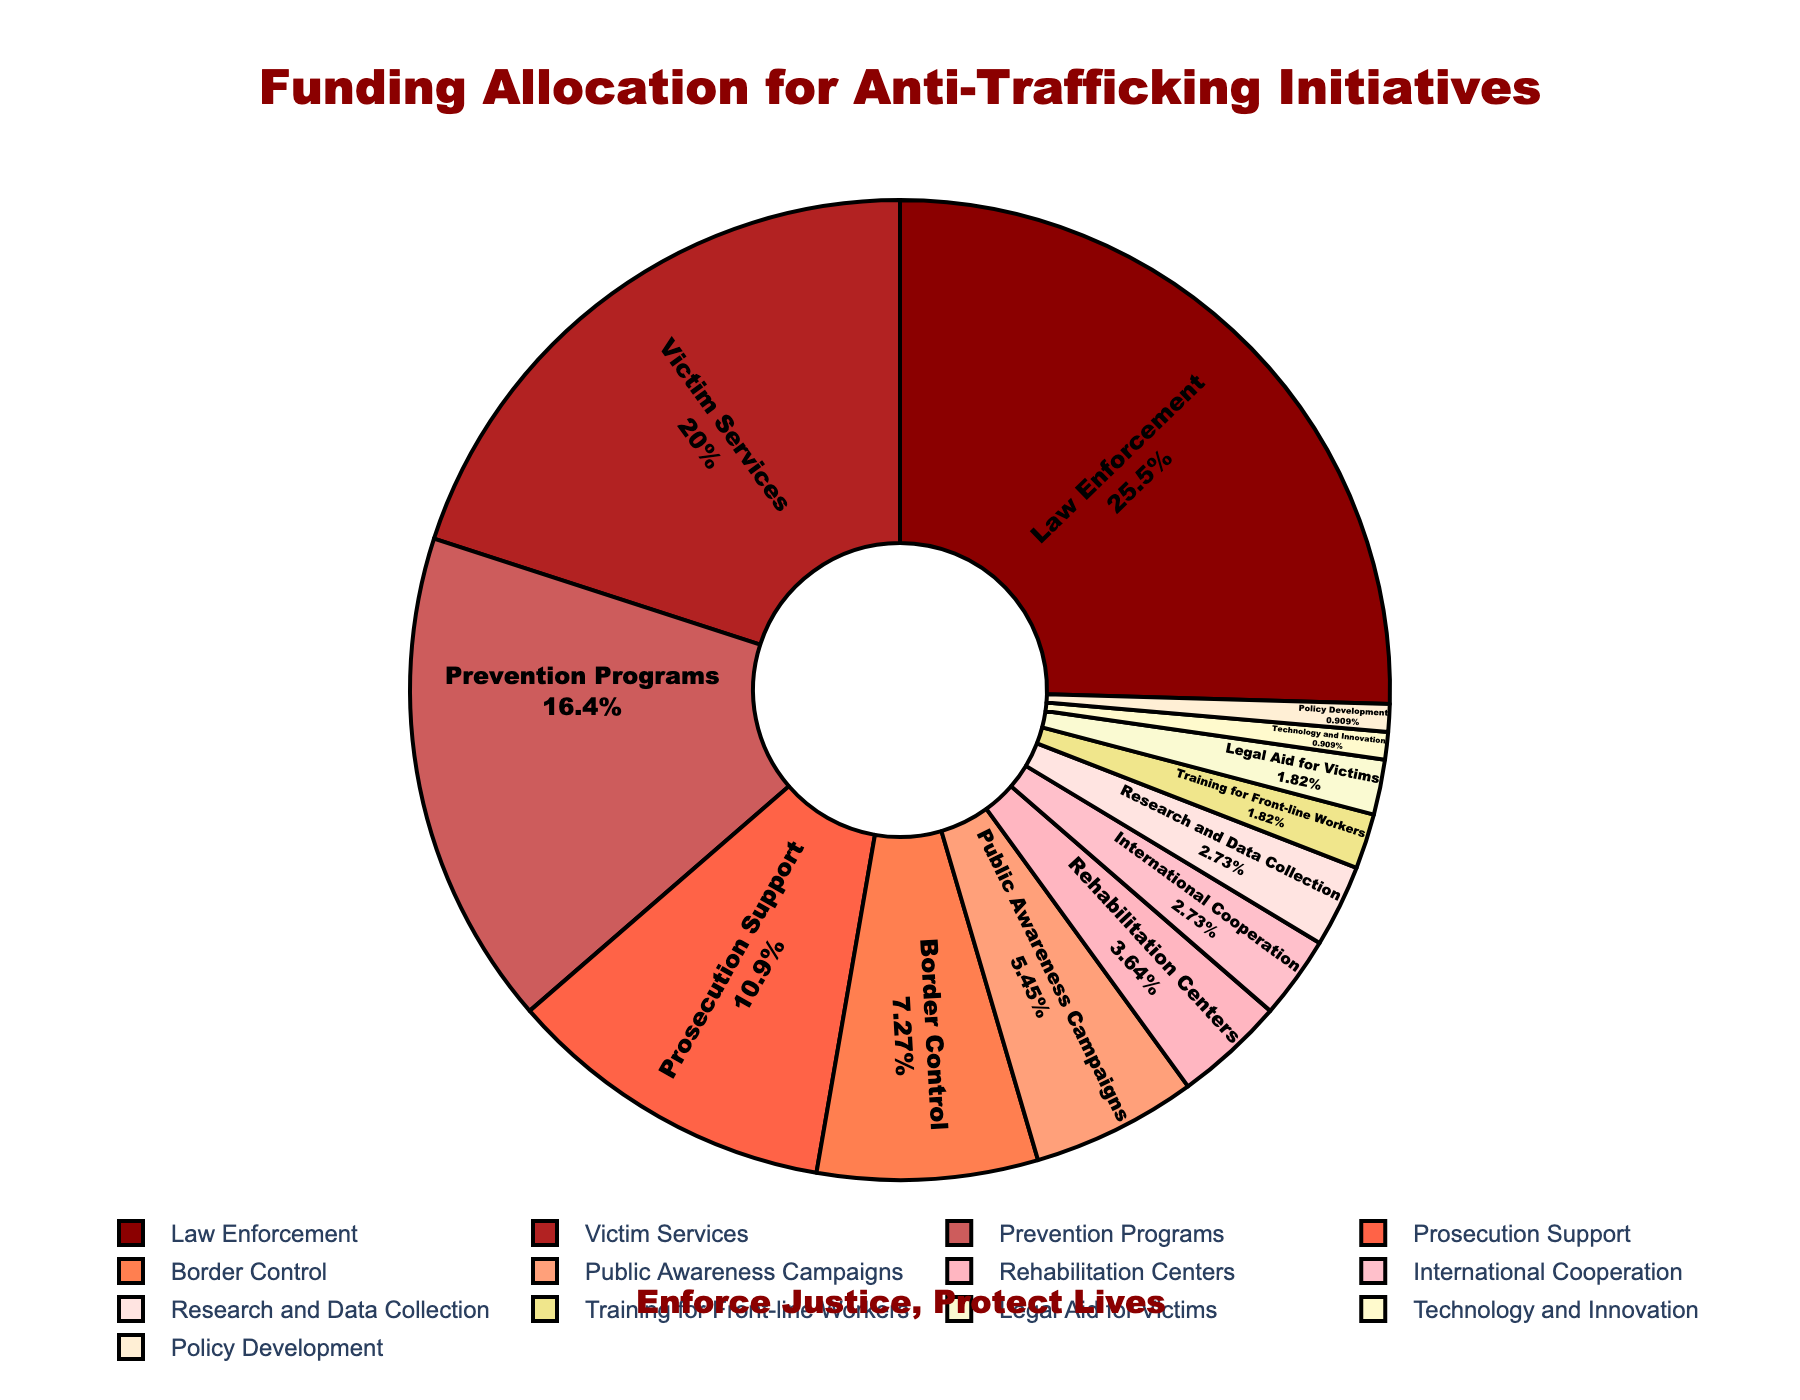Which sector receives the highest funding percentage? By examining the pie chart, we observe that the sector occupying the largest slice is labeled 'Law Enforcement'. This determination is made visually by comparing the sizes of the sections.
Answer: Law Enforcement What is the combined funding percentage for Law Enforcement and Victim Services? To find this, add the funding percentages of both sectors: 28% (Law Enforcement) + 22% (Victim Services) = 50%.
Answer: 50% Which sector has a higher funding percentage: Prevention Programs or Prosecution Support? By comparing the two slices representing the sectors, we see that the slice for Prevention Programs is larger than the slice for Prosecution Support. Specifically, Prevention Programs have 18%, while Prosecution Support has 12%.
Answer: Prevention Programs How does the funding for Border Control compare to Public Awareness Campaigns? To compare the two, look at their respective funding percentages: Border Control is allocated 8%, while Public Awareness Campaigns receive 6%. Therefore, Border Control has a higher funding percentage.
Answer: Border Control What is the total funding percentage allocated to sectors with single-digit funding percentages? Sum the funding percentages for each sector with single-digit funding: Border Control (8%) + Public Awareness Campaigns (6%) + Rehabilitation Centers (4%) + International Cooperation (3%) + Research and Data Collection (3%) + Training for Front-line Workers (2%) + Legal Aid for Victims (2%) + Technology and Innovation (1%) + Policy Development (1%) = 30%.
Answer: 30% Which sector receives the least funding and what is its percentage? By identifying the smallest slice on the pie chart labeled clearly, we find that both Technology and Innovation, and Policy Development receive the least funding, each with 1%.
Answer: Technology and Innovation, Policy Development Is the funding for Prevention Programs greater than the sum of the funding for International Cooperation and Research and Data Collection? Compare 18% (Prevention Programs) to the sum of 3% (International Cooperation) and 3% (Research and Data Collection). Since 18% > 3% + 3% = 6%, Prevention Programs have greater funding.
Answer: Yes What's the difference in funding percentage between Law Enforcement and Border Control? Subtract the funding percentage of Border Control from that of Law Enforcement: 28% - 8% = 20%.
Answer: 20% If we combine the funding percentages for Technology and Innovation with Policy Development, do they exceed the funding for Research and Data Collection alone? Add the percentages for Technology and Innovation (1%) and Policy Development (1%), then compare this sum to the percentage for Research and Data Collection. Since 1% + 1% = 2%, and 2% < 3%, they do not exceed Research and Data Collection.
Answer: No 